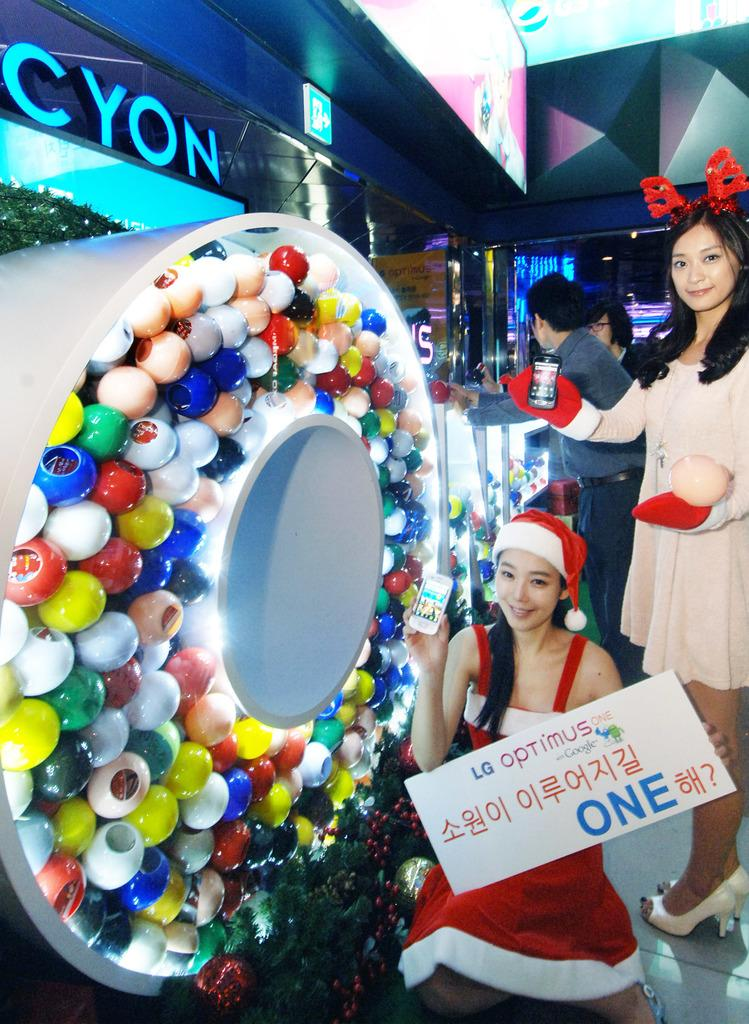How many people can be seen in the image? There are people in the image, but the exact number is not specified. What can be seen under the people's feet in the image? The ground is visible in the image. What type of objects can be seen in the image besides people? There are decorative objects in the image. What kind of boards are present in the image? There are boards with text and images in the image. Can you describe a sign in the image? There is a signboard in the image. Where is the library located in the image? There is no mention of a library in the image. How many times do the people need to wash their hands in the image? There is no indication of hand washing or any related activity in the image. 